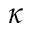<formula> <loc_0><loc_0><loc_500><loc_500>\kappa</formula> 